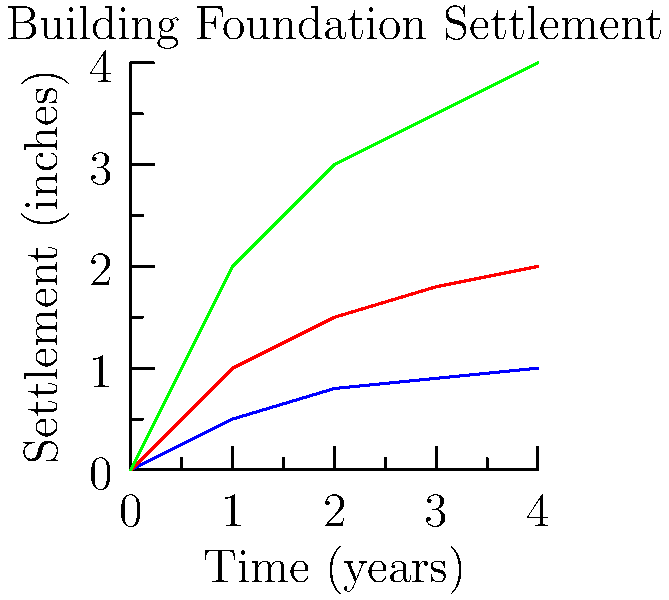In the context of classic rock studios, where stability is crucial for recording equipment, analyze the graph showing foundation settlement over time for different soil types. Which soil would be most suitable for constructing a new recording studio, and why? To answer this question, let's analyze the graph step-by-step:

1. The graph shows settlement (in inches) over time (in years) for three soil types: Sand, Clay, and Organic Soil.

2. For a recording studio, we want minimal settlement to ensure equipment stability. Let's compare the soils:

   a) Sand (blue line):
      - Initial rapid settlement, then stabilizes quickly
      - After 4 years, settles about 1 inch

   b) Clay (red line):
      - Moderate initial settlement, continues to settle over time
      - After 4 years, settles about 2 inches

   c) Organic Soil (green line):
      - Rapid and continuous settlement
      - After 4 years, settles about 4 inches

3. Comparing the three:
   - Sand has the least total settlement after 4 years
   - Sand stabilizes faster than the other soil types

4. For a recording studio:
   - Minimal settlement is crucial for equipment alignment and acoustics
   - Quick stabilization helps in setting up the studio sooner

5. Therefore, sand would be the most suitable soil for constructing a new recording studio.

The behavior of sand can be explained by its granular nature, which allows for initial compaction but reaches a stable state relatively quickly. This characteristic is ideal for maintaining the precise setup required in a recording studio environment.
Answer: Sand, due to minimal long-term settlement and quick stabilization. 